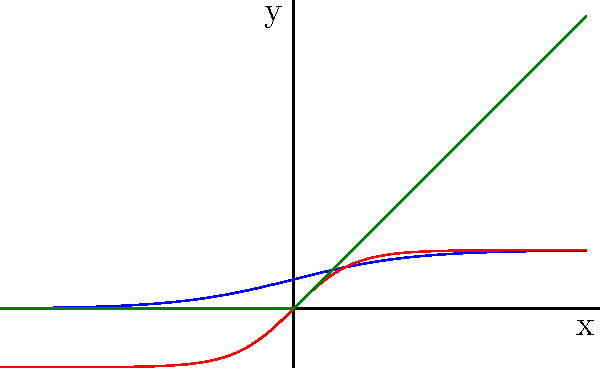Based on the graph, which activation function would be most suitable for a binary classification problem where you want to output probabilities between 0 and 1? Explain your reasoning and describe how you would implement this in Keras. To answer this question, let's analyze the characteristics of each activation function shown in the graph:

1. Sigmoid (blue curve):
   - Output range: (0, 1)
   - S-shaped curve
   - Saturates at both ends

2. Tanh (red curve):
   - Output range: (-1, 1)
   - S-shaped curve
   - Saturates at both ends

3. ReLU (green curve):
   - Output range: [0, ∞)
   - Linear for positive inputs, zero for negative inputs

For a binary classification problem with probability outputs between 0 and 1, the Sigmoid activation function is most suitable. Here's why:

1. Output range: The Sigmoid function outputs values between 0 and 1, which can be interpreted as probabilities.
2. Non-linearity: Its S-shaped curve introduces non-linearity, allowing the model to learn complex patterns.
3. Smooth gradient: Unlike ReLU, Sigmoid has a smooth gradient, which can be beneficial for optimization.

To implement this in Keras:

1. Import the necessary modules:
   ```python
   from tensorflow.keras.models import Sequential
   from tensorflow.keras.layers import Dense
   ```

2. Create a model with a Sigmoid activation in the output layer:
   ```python
   model = Sequential([
       # ... other layers ...
       Dense(1, activation='sigmoid')
   ])
   ```

3. Compile the model with binary cross-entropy loss:
   ```python
   model.compile(optimizer='adam', loss='binary_crossentropy', metrics=['accuracy'])
   ```

4. Train the model:
   ```python
   model.fit(X_train, y_train, epochs=10, batch_size=32, validation_split=0.2)
   ```

5. Use the model to predict probabilities:
   ```python
   probabilities = model.predict(X_test)
   ```

By using the Sigmoid activation function in the output layer, the model will naturally output values between 0 and 1, which can be interpreted as probabilities for binary classification.
Answer: Sigmoid; implemented as Dense(1, activation='sigmoid') in Keras output layer. 